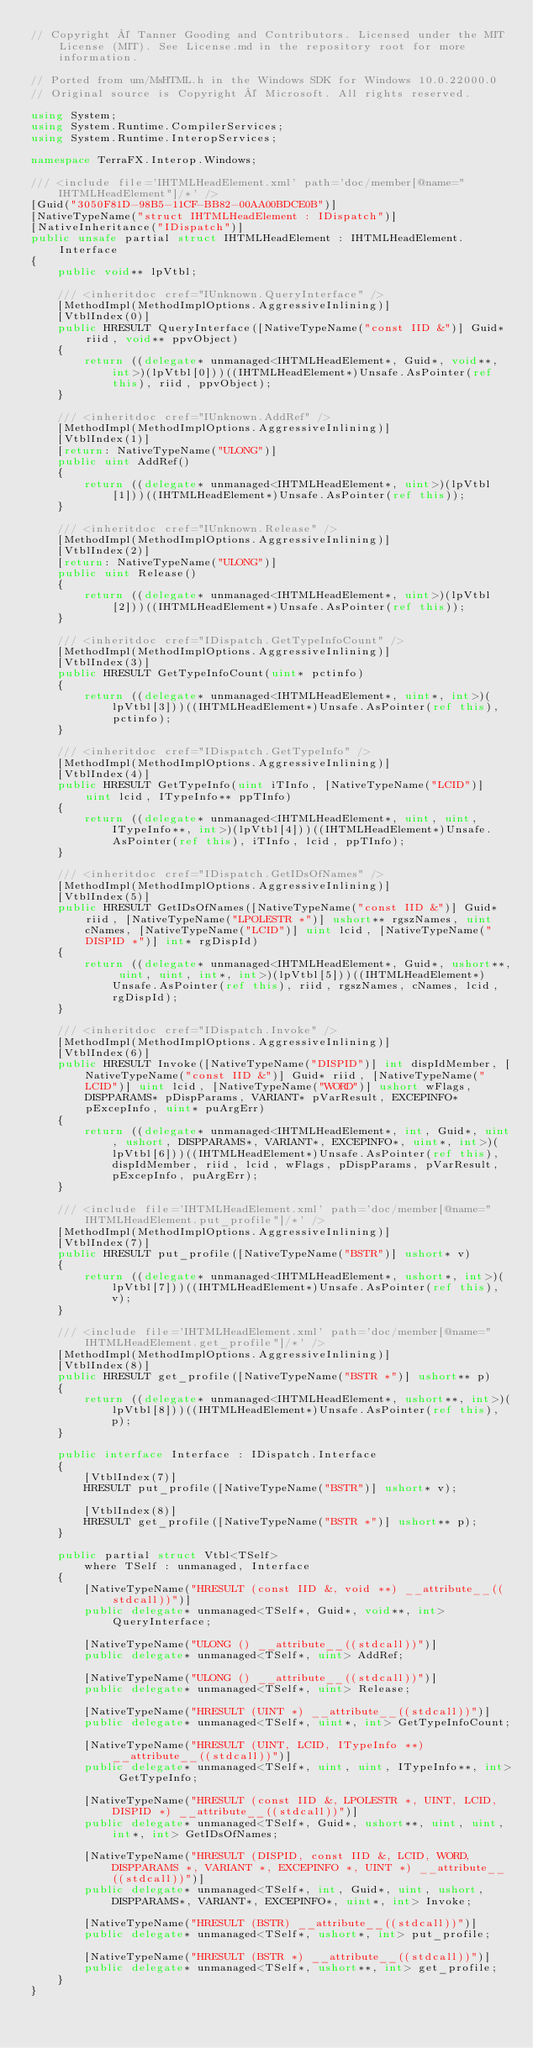Convert code to text. <code><loc_0><loc_0><loc_500><loc_500><_C#_>// Copyright © Tanner Gooding and Contributors. Licensed under the MIT License (MIT). See License.md in the repository root for more information.

// Ported from um/MsHTML.h in the Windows SDK for Windows 10.0.22000.0
// Original source is Copyright © Microsoft. All rights reserved.

using System;
using System.Runtime.CompilerServices;
using System.Runtime.InteropServices;

namespace TerraFX.Interop.Windows;

/// <include file='IHTMLHeadElement.xml' path='doc/member[@name="IHTMLHeadElement"]/*' />
[Guid("3050F81D-98B5-11CF-BB82-00AA00BDCE0B")]
[NativeTypeName("struct IHTMLHeadElement : IDispatch")]
[NativeInheritance("IDispatch")]
public unsafe partial struct IHTMLHeadElement : IHTMLHeadElement.Interface
{
    public void** lpVtbl;

    /// <inheritdoc cref="IUnknown.QueryInterface" />
    [MethodImpl(MethodImplOptions.AggressiveInlining)]
    [VtblIndex(0)]
    public HRESULT QueryInterface([NativeTypeName("const IID &")] Guid* riid, void** ppvObject)
    {
        return ((delegate* unmanaged<IHTMLHeadElement*, Guid*, void**, int>)(lpVtbl[0]))((IHTMLHeadElement*)Unsafe.AsPointer(ref this), riid, ppvObject);
    }

    /// <inheritdoc cref="IUnknown.AddRef" />
    [MethodImpl(MethodImplOptions.AggressiveInlining)]
    [VtblIndex(1)]
    [return: NativeTypeName("ULONG")]
    public uint AddRef()
    {
        return ((delegate* unmanaged<IHTMLHeadElement*, uint>)(lpVtbl[1]))((IHTMLHeadElement*)Unsafe.AsPointer(ref this));
    }

    /// <inheritdoc cref="IUnknown.Release" />
    [MethodImpl(MethodImplOptions.AggressiveInlining)]
    [VtblIndex(2)]
    [return: NativeTypeName("ULONG")]
    public uint Release()
    {
        return ((delegate* unmanaged<IHTMLHeadElement*, uint>)(lpVtbl[2]))((IHTMLHeadElement*)Unsafe.AsPointer(ref this));
    }

    /// <inheritdoc cref="IDispatch.GetTypeInfoCount" />
    [MethodImpl(MethodImplOptions.AggressiveInlining)]
    [VtblIndex(3)]
    public HRESULT GetTypeInfoCount(uint* pctinfo)
    {
        return ((delegate* unmanaged<IHTMLHeadElement*, uint*, int>)(lpVtbl[3]))((IHTMLHeadElement*)Unsafe.AsPointer(ref this), pctinfo);
    }

    /// <inheritdoc cref="IDispatch.GetTypeInfo" />
    [MethodImpl(MethodImplOptions.AggressiveInlining)]
    [VtblIndex(4)]
    public HRESULT GetTypeInfo(uint iTInfo, [NativeTypeName("LCID")] uint lcid, ITypeInfo** ppTInfo)
    {
        return ((delegate* unmanaged<IHTMLHeadElement*, uint, uint, ITypeInfo**, int>)(lpVtbl[4]))((IHTMLHeadElement*)Unsafe.AsPointer(ref this), iTInfo, lcid, ppTInfo);
    }

    /// <inheritdoc cref="IDispatch.GetIDsOfNames" />
    [MethodImpl(MethodImplOptions.AggressiveInlining)]
    [VtblIndex(5)]
    public HRESULT GetIDsOfNames([NativeTypeName("const IID &")] Guid* riid, [NativeTypeName("LPOLESTR *")] ushort** rgszNames, uint cNames, [NativeTypeName("LCID")] uint lcid, [NativeTypeName("DISPID *")] int* rgDispId)
    {
        return ((delegate* unmanaged<IHTMLHeadElement*, Guid*, ushort**, uint, uint, int*, int>)(lpVtbl[5]))((IHTMLHeadElement*)Unsafe.AsPointer(ref this), riid, rgszNames, cNames, lcid, rgDispId);
    }

    /// <inheritdoc cref="IDispatch.Invoke" />
    [MethodImpl(MethodImplOptions.AggressiveInlining)]
    [VtblIndex(6)]
    public HRESULT Invoke([NativeTypeName("DISPID")] int dispIdMember, [NativeTypeName("const IID &")] Guid* riid, [NativeTypeName("LCID")] uint lcid, [NativeTypeName("WORD")] ushort wFlags, DISPPARAMS* pDispParams, VARIANT* pVarResult, EXCEPINFO* pExcepInfo, uint* puArgErr)
    {
        return ((delegate* unmanaged<IHTMLHeadElement*, int, Guid*, uint, ushort, DISPPARAMS*, VARIANT*, EXCEPINFO*, uint*, int>)(lpVtbl[6]))((IHTMLHeadElement*)Unsafe.AsPointer(ref this), dispIdMember, riid, lcid, wFlags, pDispParams, pVarResult, pExcepInfo, puArgErr);
    }

    /// <include file='IHTMLHeadElement.xml' path='doc/member[@name="IHTMLHeadElement.put_profile"]/*' />
    [MethodImpl(MethodImplOptions.AggressiveInlining)]
    [VtblIndex(7)]
    public HRESULT put_profile([NativeTypeName("BSTR")] ushort* v)
    {
        return ((delegate* unmanaged<IHTMLHeadElement*, ushort*, int>)(lpVtbl[7]))((IHTMLHeadElement*)Unsafe.AsPointer(ref this), v);
    }

    /// <include file='IHTMLHeadElement.xml' path='doc/member[@name="IHTMLHeadElement.get_profile"]/*' />
    [MethodImpl(MethodImplOptions.AggressiveInlining)]
    [VtblIndex(8)]
    public HRESULT get_profile([NativeTypeName("BSTR *")] ushort** p)
    {
        return ((delegate* unmanaged<IHTMLHeadElement*, ushort**, int>)(lpVtbl[8]))((IHTMLHeadElement*)Unsafe.AsPointer(ref this), p);
    }

    public interface Interface : IDispatch.Interface
    {
        [VtblIndex(7)]
        HRESULT put_profile([NativeTypeName("BSTR")] ushort* v);

        [VtblIndex(8)]
        HRESULT get_profile([NativeTypeName("BSTR *")] ushort** p);
    }

    public partial struct Vtbl<TSelf>
        where TSelf : unmanaged, Interface
    {
        [NativeTypeName("HRESULT (const IID &, void **) __attribute__((stdcall))")]
        public delegate* unmanaged<TSelf*, Guid*, void**, int> QueryInterface;

        [NativeTypeName("ULONG () __attribute__((stdcall))")]
        public delegate* unmanaged<TSelf*, uint> AddRef;

        [NativeTypeName("ULONG () __attribute__((stdcall))")]
        public delegate* unmanaged<TSelf*, uint> Release;

        [NativeTypeName("HRESULT (UINT *) __attribute__((stdcall))")]
        public delegate* unmanaged<TSelf*, uint*, int> GetTypeInfoCount;

        [NativeTypeName("HRESULT (UINT, LCID, ITypeInfo **) __attribute__((stdcall))")]
        public delegate* unmanaged<TSelf*, uint, uint, ITypeInfo**, int> GetTypeInfo;

        [NativeTypeName("HRESULT (const IID &, LPOLESTR *, UINT, LCID, DISPID *) __attribute__((stdcall))")]
        public delegate* unmanaged<TSelf*, Guid*, ushort**, uint, uint, int*, int> GetIDsOfNames;

        [NativeTypeName("HRESULT (DISPID, const IID &, LCID, WORD, DISPPARAMS *, VARIANT *, EXCEPINFO *, UINT *) __attribute__((stdcall))")]
        public delegate* unmanaged<TSelf*, int, Guid*, uint, ushort, DISPPARAMS*, VARIANT*, EXCEPINFO*, uint*, int> Invoke;

        [NativeTypeName("HRESULT (BSTR) __attribute__((stdcall))")]
        public delegate* unmanaged<TSelf*, ushort*, int> put_profile;

        [NativeTypeName("HRESULT (BSTR *) __attribute__((stdcall))")]
        public delegate* unmanaged<TSelf*, ushort**, int> get_profile;
    }
}
</code> 